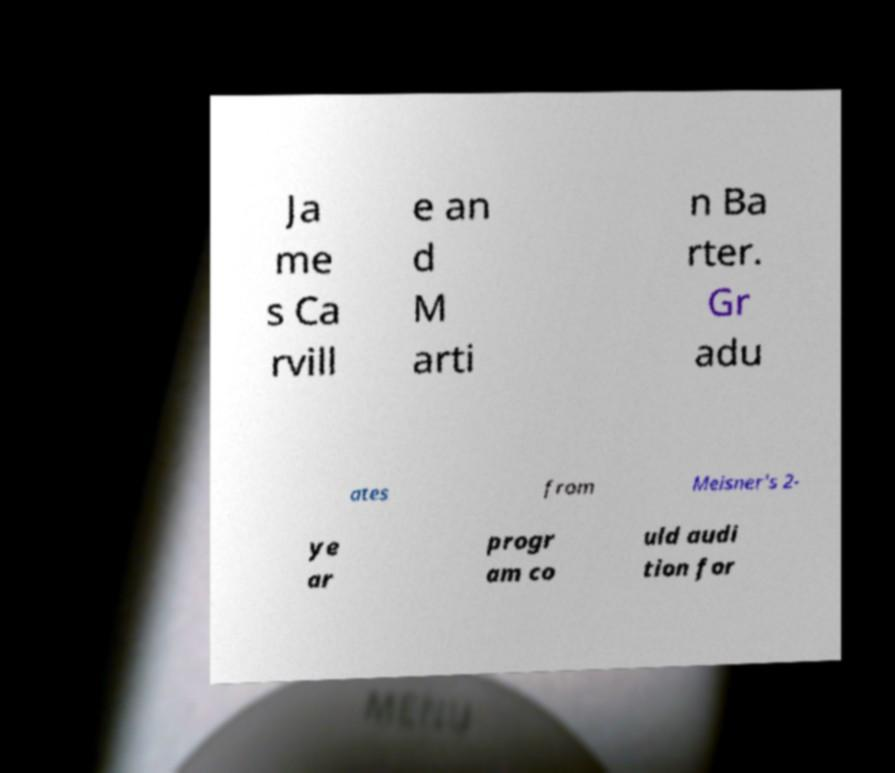There's text embedded in this image that I need extracted. Can you transcribe it verbatim? Ja me s Ca rvill e an d M arti n Ba rter. Gr adu ates from Meisner's 2- ye ar progr am co uld audi tion for 